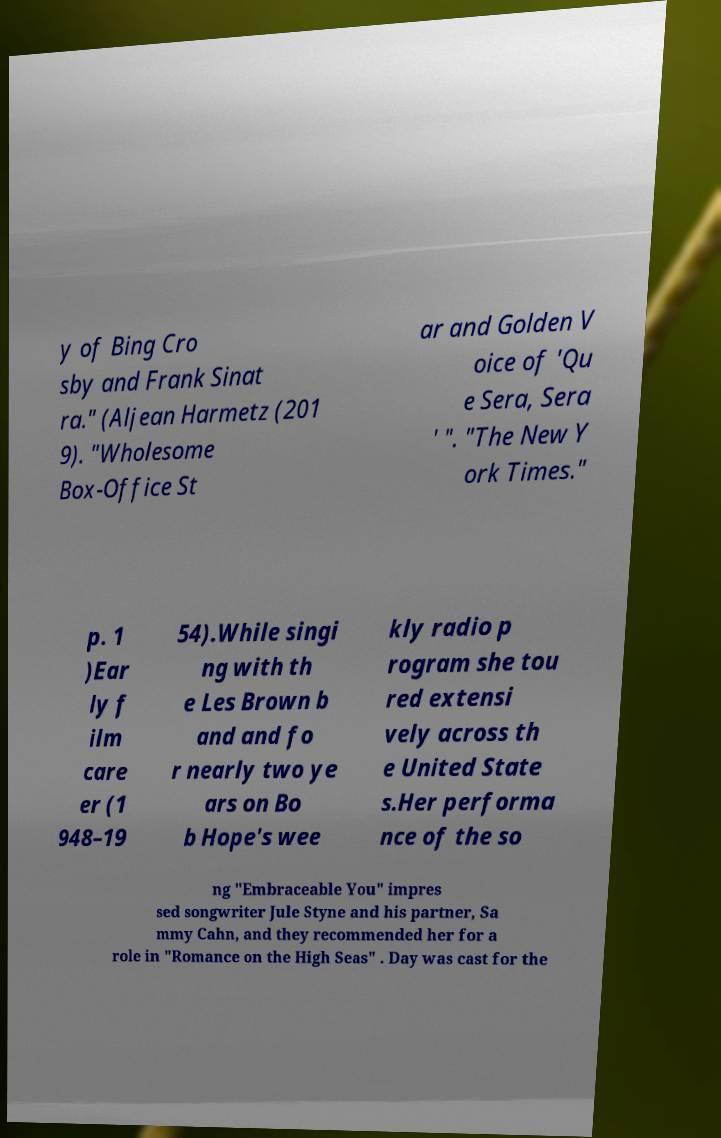There's text embedded in this image that I need extracted. Can you transcribe it verbatim? y of Bing Cro sby and Frank Sinat ra." (Aljean Harmetz (201 9). "Wholesome Box-Office St ar and Golden V oice of 'Qu e Sera, Sera ' ". "The New Y ork Times." p. 1 )Ear ly f ilm care er (1 948–19 54).While singi ng with th e Les Brown b and and fo r nearly two ye ars on Bo b Hope's wee kly radio p rogram she tou red extensi vely across th e United State s.Her performa nce of the so ng "Embraceable You" impres sed songwriter Jule Styne and his partner, Sa mmy Cahn, and they recommended her for a role in "Romance on the High Seas" . Day was cast for the 